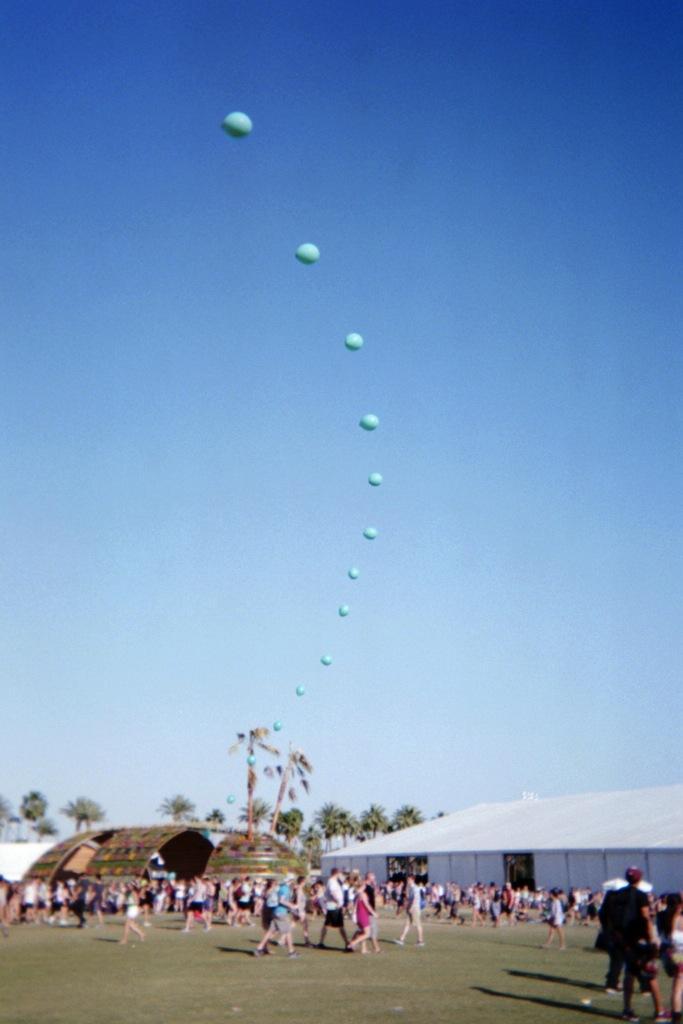In one or two sentences, can you explain what this image depicts? In this picture we can see some people walking, at the bottom there is grass, on the right side we can see a shed, in the background there are some trees, we can see balloons and the sky at the top of the picture. 